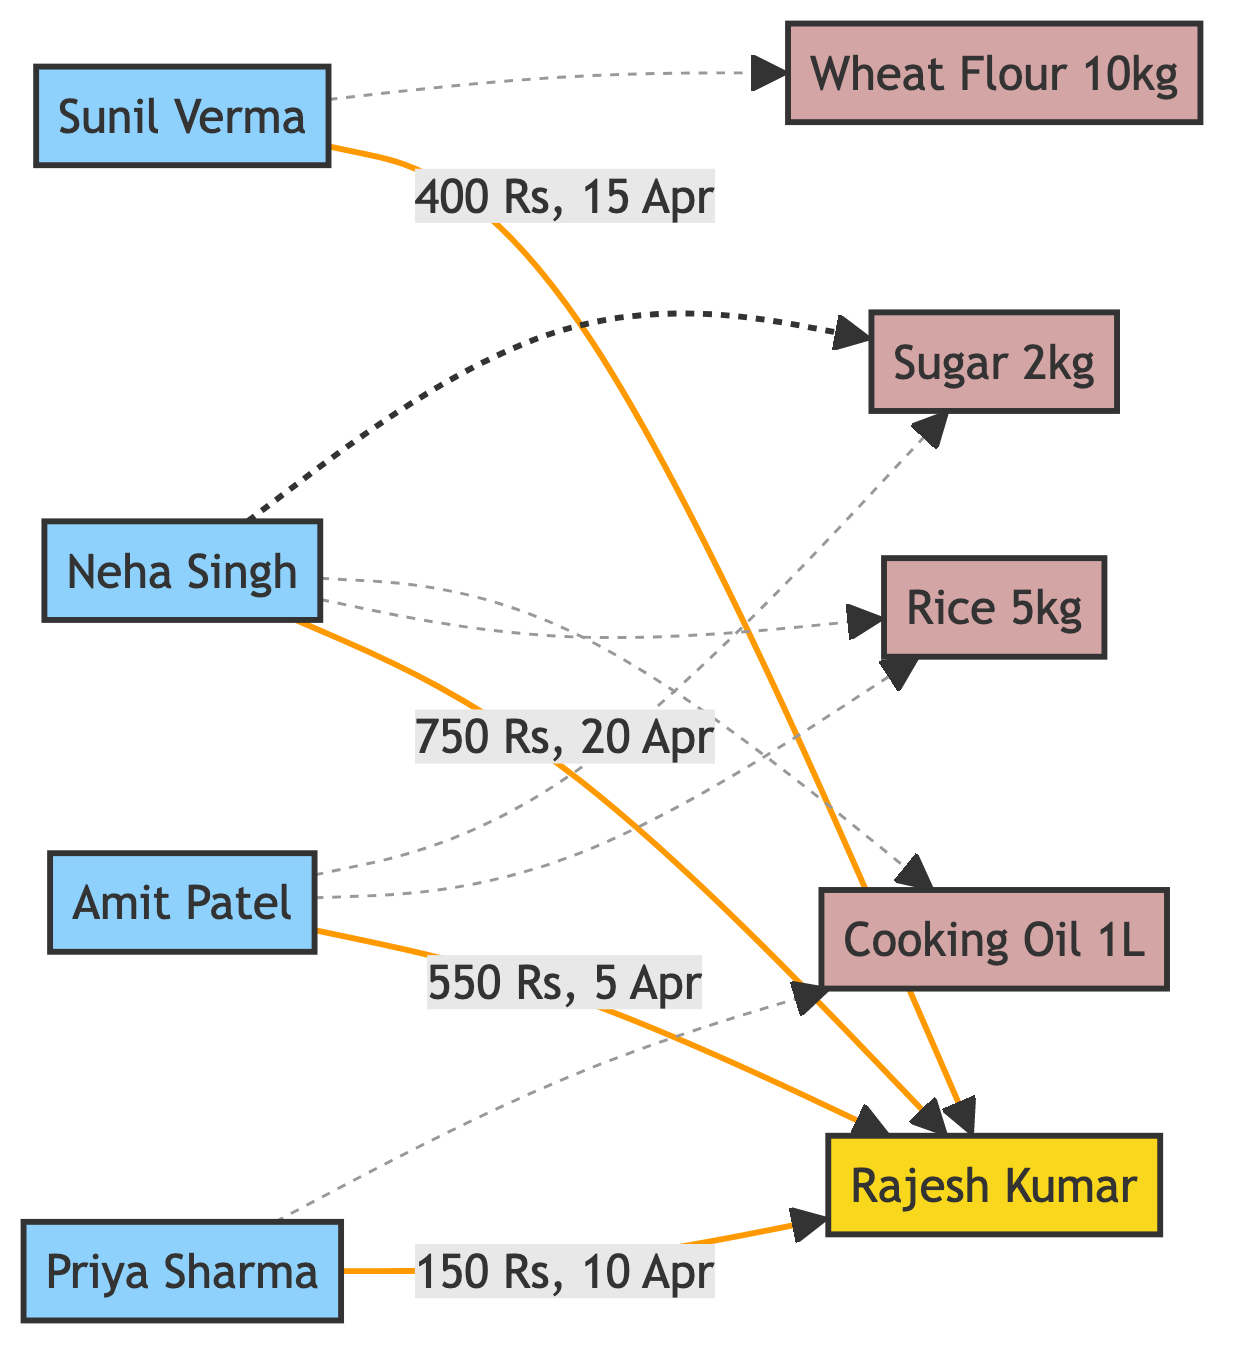What is the total number of customers in the diagram? The diagram includes four customer nodes: Amit Patel, Priya Sharma, Sunil Verma, and Neha Singh. Counting these gives a total of 4 customers.
Answer: 4 Who made a transaction on April 5th? The only transaction that occurred on April 5th is linked to Amit Patel, who is connected to Rajesh Kumar in the diagram.
Answer: Amit Patel How much did Neha Singh spend on her transaction? The edge from Neha Singh to Rajesh Kumar indicates a transaction amount of 750.
Answer: 750 What products did Amit Patel purchase? The diagram shows a dashed line from Amit Patel to the products Rice 5kg and Sugar 2kg, indicating these are the products he purchased.
Answer: Rice 5kg, Sugar 2kg Which customer made the highest transaction amount? Among the transactions listed, Neha Singh spent 750, which is higher than the other amounts (550, 150, and 400).
Answer: Neha Singh How many products are shown in the diagram? The diagram displays four unique product nodes: Rice 5kg, Cooking Oil 1L, Wheat Flour 10kg, and Sugar 2kg. Counting these gives a total of 4 products.
Answer: 4 What is the relationship between Priya Sharma and Rajesh Kumar? Priya Sharma is a customer who made a transaction to Rajesh Kumar. In the diagram, there is a direct edge from Priya Sharma to Rajesh Kumar.
Answer: Transaction List the transaction date for Sunil Verma. The edge connected to Sunil Verma indicates that the transaction date is April 15, 2023.
Answer: April 15 Which product is purchased by both Amit Patel and Neha Singh? Both customers have a dashed line connecting to Rice 5kg, indicating that it is the common product purchased by them.
Answer: Rice 5kg 